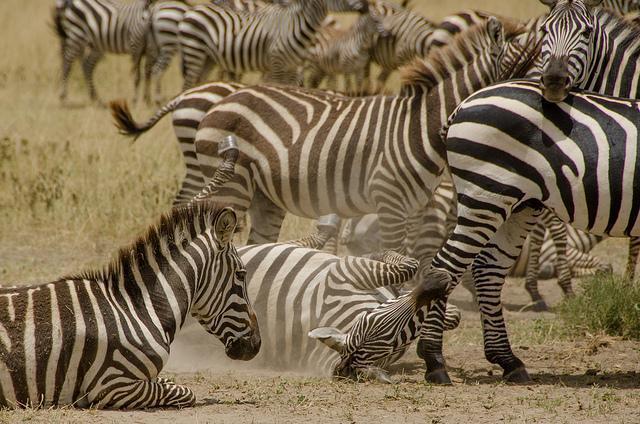How would these animals be classified?
Indicate the correct response by choosing from the four available options to answer the question.
Options: Pescatarian, omnivores, carnivores, herbivores. Herbivores. 